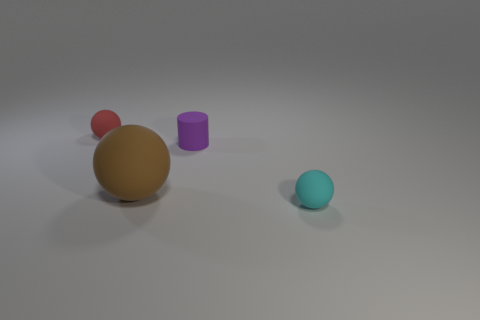Subtract all tiny spheres. How many spheres are left? 1 Add 2 big cyan cubes. How many objects exist? 6 Subtract all cyan balls. How many balls are left? 2 Subtract all spheres. How many objects are left? 1 Subtract all yellow cubes. How many red balls are left? 1 Add 2 purple matte things. How many purple matte things exist? 3 Subtract 1 purple cylinders. How many objects are left? 3 Subtract 1 cylinders. How many cylinders are left? 0 Subtract all blue cylinders. Subtract all purple spheres. How many cylinders are left? 1 Subtract all red spheres. Subtract all green shiny blocks. How many objects are left? 3 